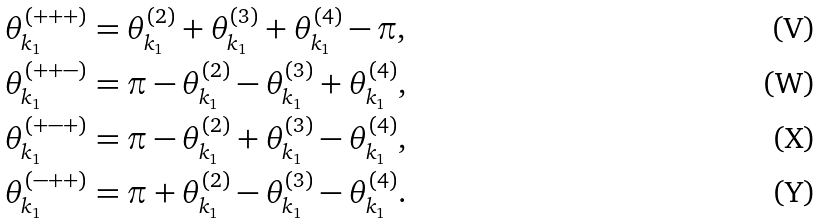Convert formula to latex. <formula><loc_0><loc_0><loc_500><loc_500>\theta ^ { ( + + + ) } _ { k _ { 1 } } = \theta ^ { ( 2 ) } _ { k _ { 1 } } + \theta ^ { ( 3 ) } _ { k _ { 1 } } + \theta ^ { ( 4 ) } _ { k _ { 1 } } - \pi , \\ \theta ^ { ( + + - ) } _ { k _ { 1 } } = \pi - \theta ^ { ( 2 ) } _ { k _ { 1 } } - \theta ^ { ( 3 ) } _ { k _ { 1 } } + \theta ^ { ( 4 ) } _ { k _ { 1 } } , \\ \theta ^ { ( + - + ) } _ { k _ { 1 } } = \pi - \theta ^ { ( 2 ) } _ { k _ { 1 } } + \theta ^ { ( 3 ) } _ { k _ { 1 } } - \theta ^ { ( 4 ) } _ { k _ { 1 } } , \\ \theta ^ { ( - + + ) } _ { k _ { 1 } } = \pi + \theta ^ { ( 2 ) } _ { k _ { 1 } } - \theta ^ { ( 3 ) } _ { k _ { 1 } } - \theta ^ { ( 4 ) } _ { k _ { 1 } } .</formula> 